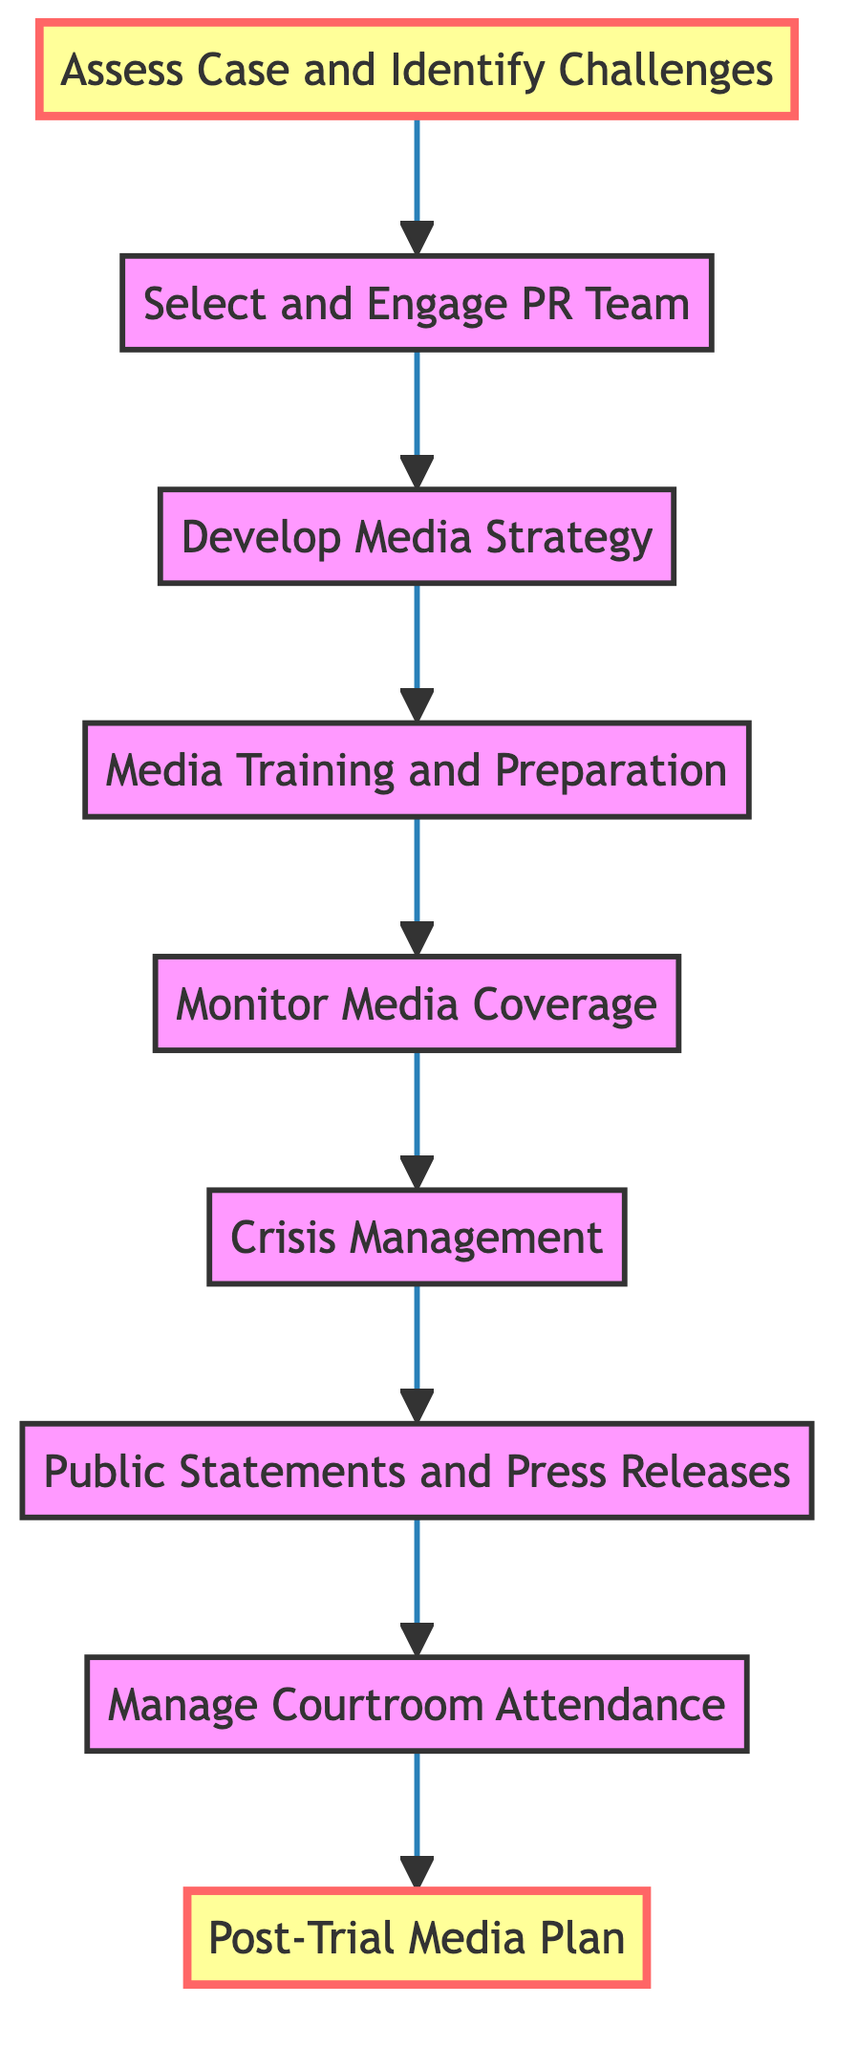What is the first step in the media management strategy? The first step in the diagram is "Assess Case and Identify Challenges," which can be determined by looking at the initial node.
Answer: Assess Case and Identify Challenges How many steps are in the media management strategy? By counting the individual nodes in the diagram, there are nine steps in total.
Answer: 9 What step follows "Crisis Management"? The diagram shows an arrow leading from "Crisis Management" to "Public Statements and Press Releases," indicating that it is the next step.
Answer: Public Statements and Press Releases What is the last step in the media management strategy? The last node in the diagram is "Post-Trial Media Plan," as it has no subsequent steps leading from it.
Answer: Post-Trial Media Plan Which step comes immediately after "Media Training and Preparation"? The flowchart indicates that "Monitor Media Coverage" directly follows "Media Training and Preparation."
Answer: Monitor Media Coverage How does "Select and Engage PR Team" relate to "Develop Media Strategy"? The diagram shows a direct connection from "Select and Engage PR Team" to "Develop Media Strategy," indicating a sequential relationship where engaging a PR team leads to the development of media strategy.
Answer: Develop Media Strategy What is the purpose of the "Crisis Management" step? The "Crisis Management" step is designed to prepare for unexpected media issues or negative coverage, which can be inferred from its description.
Answer: Develop a plan for crisis management What step immediately precedes "Manage Courtroom Attendance"? Following the flow of the diagram, "Public Statements and Press Releases" is the step that comes before "Manage Courtroom Attendance."
Answer: Public Statements and Press Releases What key action is associated with the "Monitor Media Coverage" step? The key action in "Monitor Media Coverage" is continuous monitoring and maintaining a real-time media tracker, which is stated in its description.
Answer: Continuously monitor media coverage 